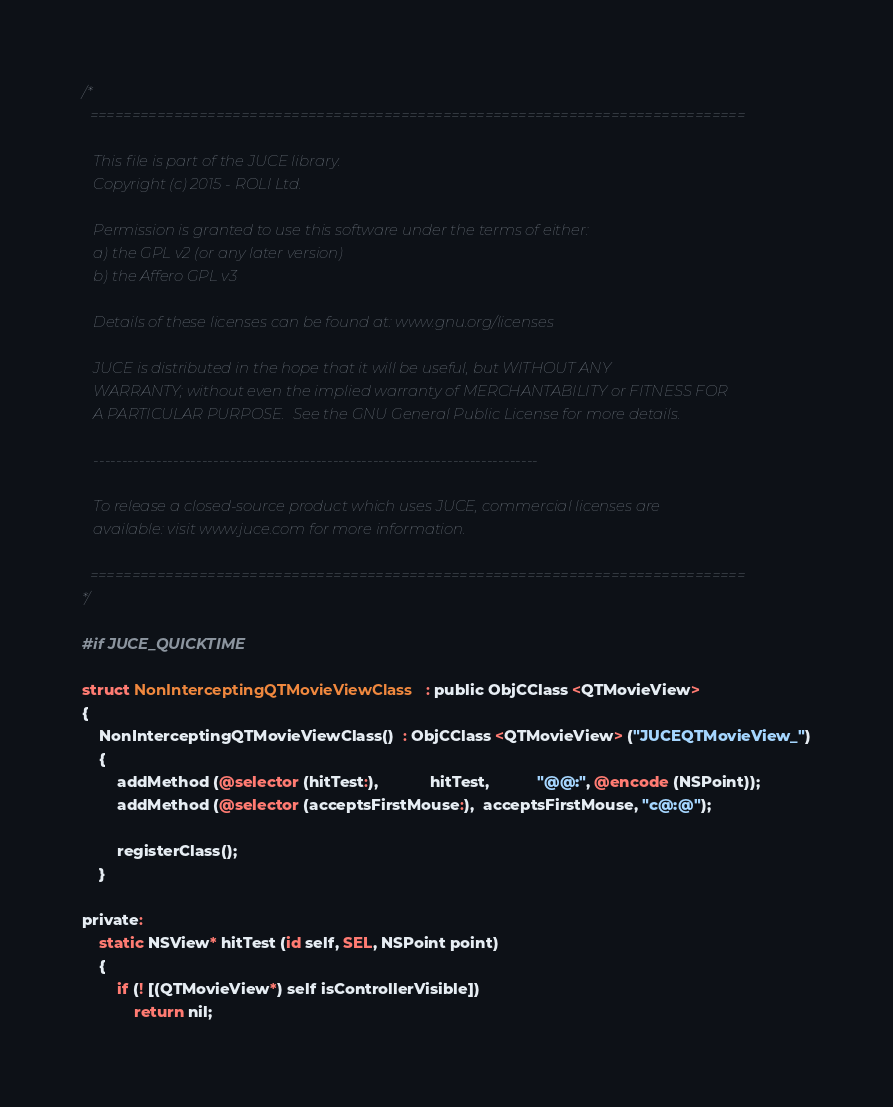<code> <loc_0><loc_0><loc_500><loc_500><_ObjectiveC_>/*
  ==============================================================================

   This file is part of the JUCE library.
   Copyright (c) 2015 - ROLI Ltd.

   Permission is granted to use this software under the terms of either:
   a) the GPL v2 (or any later version)
   b) the Affero GPL v3

   Details of these licenses can be found at: www.gnu.org/licenses

   JUCE is distributed in the hope that it will be useful, but WITHOUT ANY
   WARRANTY; without even the implied warranty of MERCHANTABILITY or FITNESS FOR
   A PARTICULAR PURPOSE.  See the GNU General Public License for more details.

   ------------------------------------------------------------------------------

   To release a closed-source product which uses JUCE, commercial licenses are
   available: visit www.juce.com for more information.

  ==============================================================================
*/

#if JUCE_QUICKTIME

struct NonInterceptingQTMovieViewClass  : public ObjCClass <QTMovieView>
{
    NonInterceptingQTMovieViewClass()  : ObjCClass <QTMovieView> ("JUCEQTMovieView_")
    {
        addMethod (@selector (hitTest:),            hitTest,           "@@:", @encode (NSPoint));
        addMethod (@selector (acceptsFirstMouse:),  acceptsFirstMouse, "c@:@");

        registerClass();
    }

private:
    static NSView* hitTest (id self, SEL, NSPoint point)
    {
        if (! [(QTMovieView*) self isControllerVisible])
            return nil;
</code> 